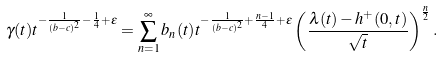<formula> <loc_0><loc_0><loc_500><loc_500>\gamma ( t ) t ^ { - \frac { 1 } { ( b - c ) ^ { 2 } } - \frac { 1 } { 4 } + \varepsilon } = \sum _ { n = 1 } ^ { \infty } b _ { n } ( t ) t ^ { - \frac { 1 } { ( b - c ) ^ { 2 } } + \frac { n - 1 } { 4 } + \varepsilon } \left ( \frac { \lambda ( t ) - h ^ { + } ( 0 , t ) } { \sqrt { t } } \right ) ^ { \frac { n } { 2 } } .</formula> 